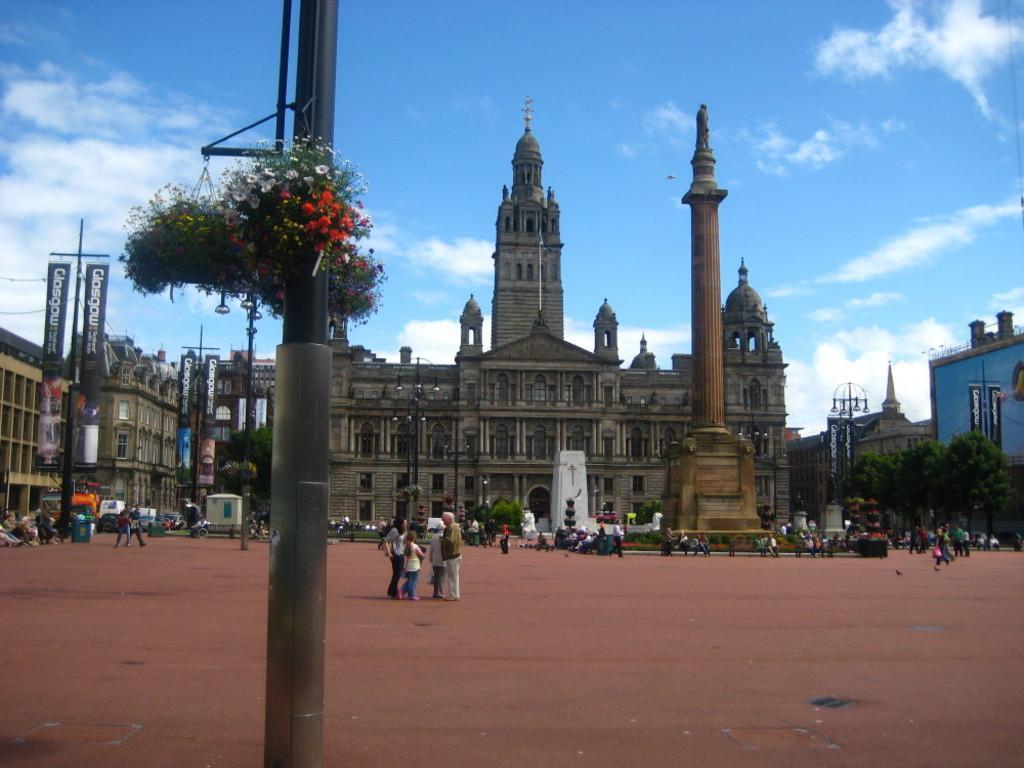Describe this image in one or two sentences. We can see plants with flowers on pole. Background we can see people, buildings,trees,sculpture on tower,banner and lights on poles and sky. 